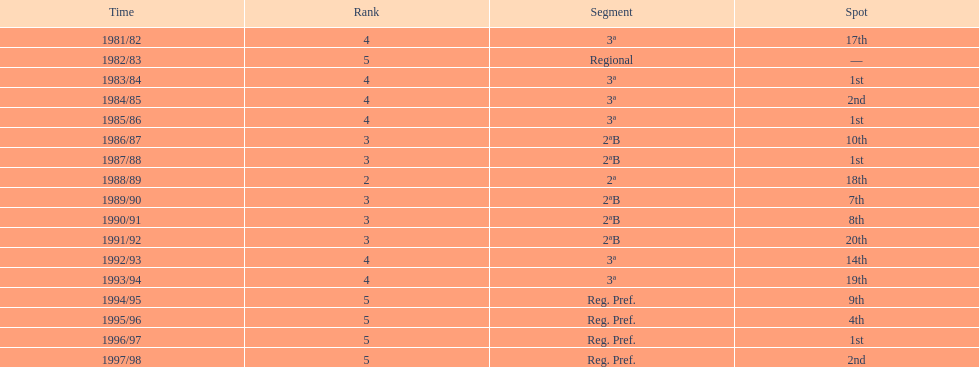What year has no place indicated? 1982/83. 